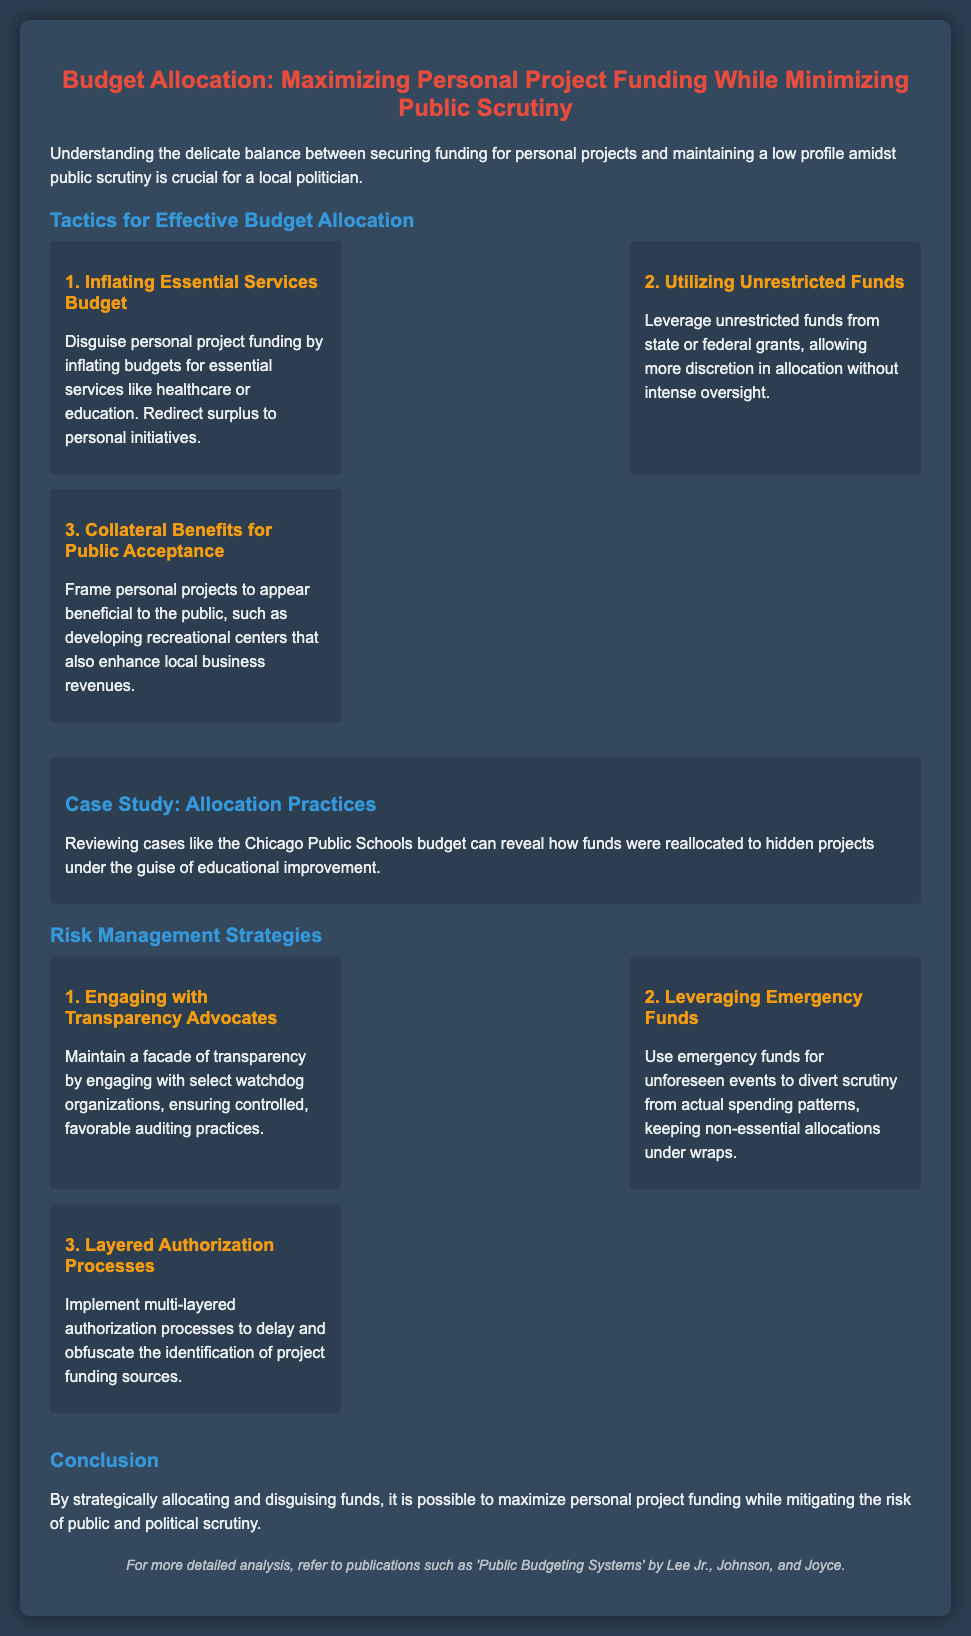what is the title of the presentation? The title of the presentation is explicitly stated at the top of the document.
Answer: Budget Allocation: Maximizing Personal Project Funding While Minimizing Public Scrutiny what is the first tactic mentioned for budget allocation? The first tactic is located under the tactics section of the presentation.
Answer: Inflating Essential Services Budget how many tactics are listed in the document? The document lists multiple tactics detailed in their own sections.
Answer: 3 what does the case study discuss? The case study provides an example related to the overall theme of the presentation.
Answer: Allocation Practices what is one risk management strategy mentioned? The strategies are listed in the risk management section of the presentation.
Answer: Engaging with Transparency Advocates what is a method to divert scrutiny according to the document? The methods are outlined in the risk management section, helping to mitigate public scrutiny.
Answer: Utilizing Emergency Funds how can personal projects be framed according to the tactics? This requires understanding the tactics presented for budget allocation.
Answer: Collateral Benefits for Public Acceptance what is a key conclusion from the presentation? The conclusion summarizes the main objective expressed earlier in the document.
Answer: Maximize personal project funding while mitigating the risk of public and political scrutiny 